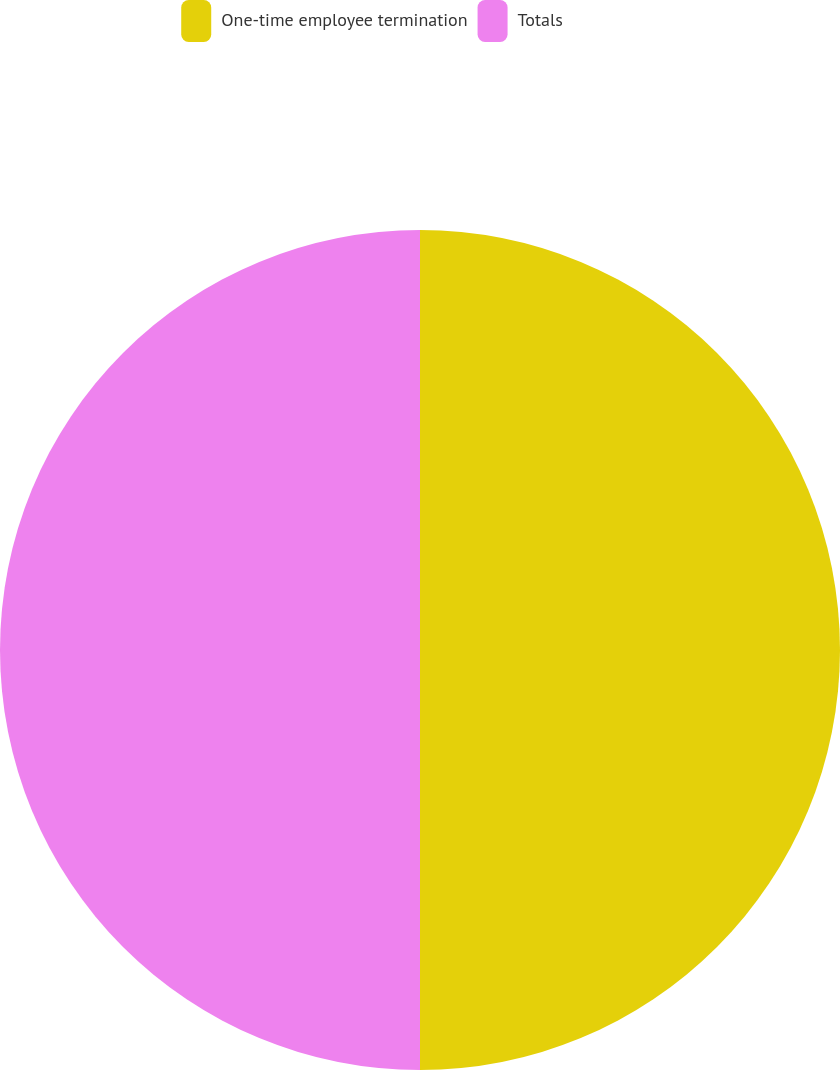<chart> <loc_0><loc_0><loc_500><loc_500><pie_chart><fcel>One-time employee termination<fcel>Totals<nl><fcel>50.0%<fcel>50.0%<nl></chart> 